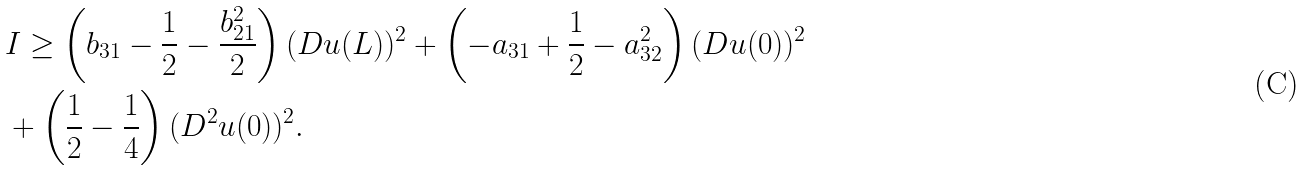<formula> <loc_0><loc_0><loc_500><loc_500>& I \geq \left ( b _ { 3 1 } - \frac { 1 } { 2 } - \frac { b _ { 2 1 } ^ { 2 } } { 2 } \right ) ( D u ( L ) ) ^ { 2 } + \left ( - a _ { 3 1 } + \frac { 1 } { 2 } - a _ { 3 2 } ^ { 2 } \right ) ( D u ( 0 ) ) ^ { 2 } \\ & + \left ( \frac { 1 } { 2 } - \frac { 1 } { 4 } \right ) ( D ^ { 2 } u ( 0 ) ) ^ { 2 } .</formula> 